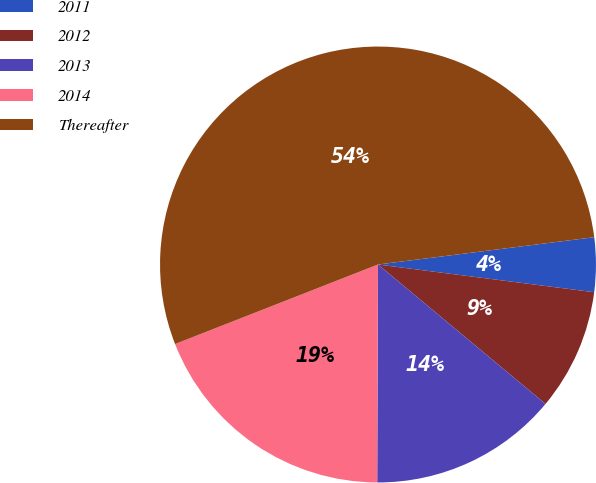<chart> <loc_0><loc_0><loc_500><loc_500><pie_chart><fcel>2011<fcel>2012<fcel>2013<fcel>2014<fcel>Thereafter<nl><fcel>4.03%<fcel>9.02%<fcel>14.01%<fcel>19.0%<fcel>53.95%<nl></chart> 